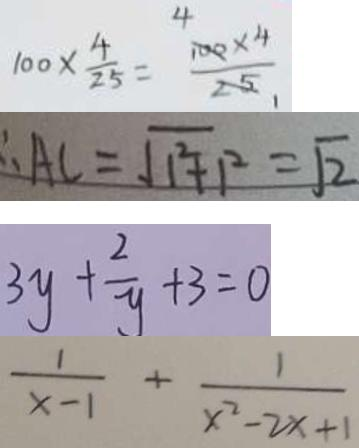<formula> <loc_0><loc_0><loc_500><loc_500>1 0 0 \times \frac { 4 } { 2 5 } = \frac { 1 0 0 \times 4 } { 2 5 } 
 \therefore A C = \sqrt { 1 ^ { 2 } + 1 ^ { 2 } } = \sqrt { 2 } 
 3 y + \frac { 2 } { y } + 3 = 0 
 \frac { 1 } { x - 1 } + \frac { 1 } { x ^ { 2 } - 2 x + 1 }</formula> 